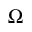<formula> <loc_0><loc_0><loc_500><loc_500>\Omega</formula> 